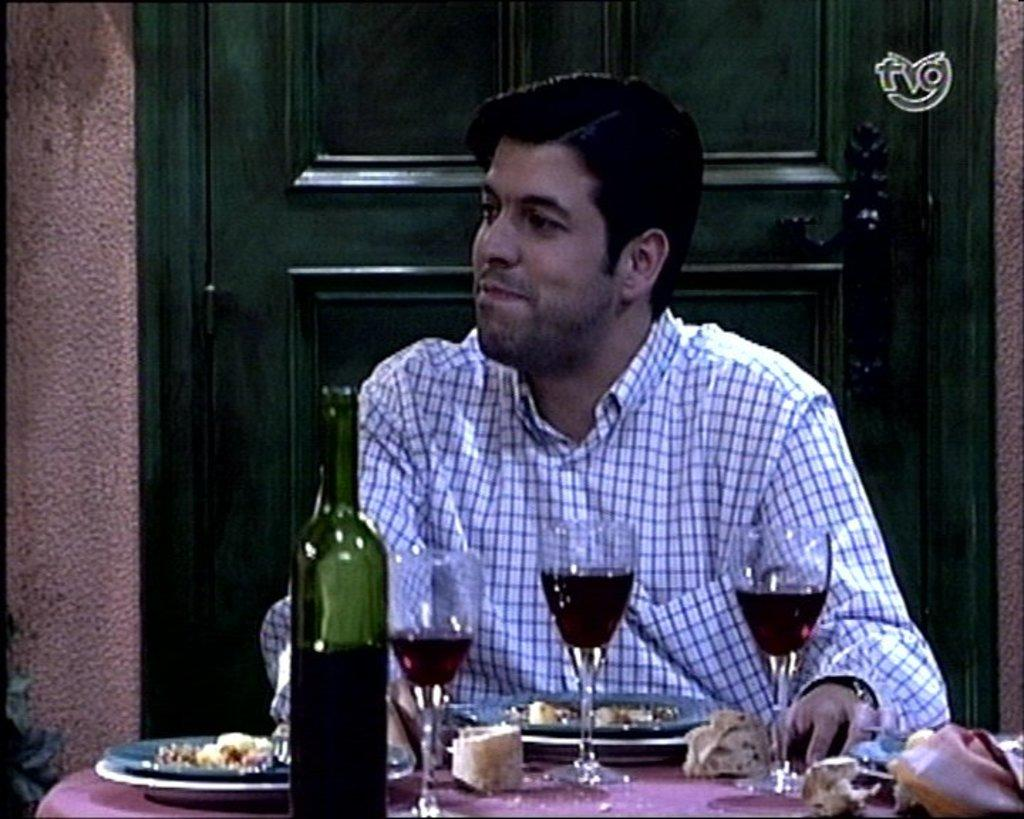What is the man in the image doing? The man is sitting on a chair in the image. What is located near the man? There is a table in the image. What items can be seen on the table? There are glasses, plates, and a bottle on the table. What can be seen in the background of the image? There is a door and a wall in the background of the image. Can you see a bat flying around in the image? There is no bat present in the image. What type of school is visible in the background of the image? There is no school present in the image; only a door and a wall can be seen in the background. 